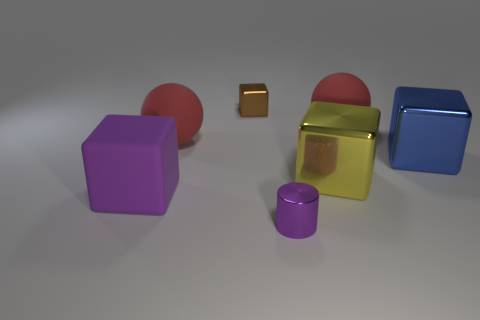Add 2 blocks. How many objects exist? 9 Subtract all cylinders. How many objects are left? 6 Subtract all yellow cubes. Subtract all tiny gray matte objects. How many objects are left? 6 Add 7 purple objects. How many purple objects are left? 9 Add 1 red rubber objects. How many red rubber objects exist? 3 Subtract 0 cyan cubes. How many objects are left? 7 